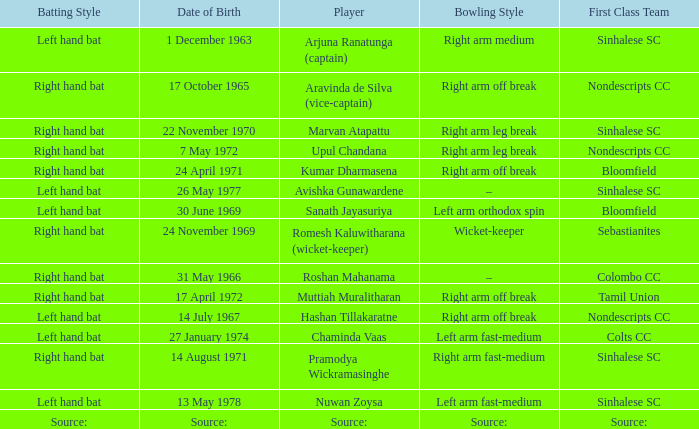Who has a bowling style of source:? Source:. 